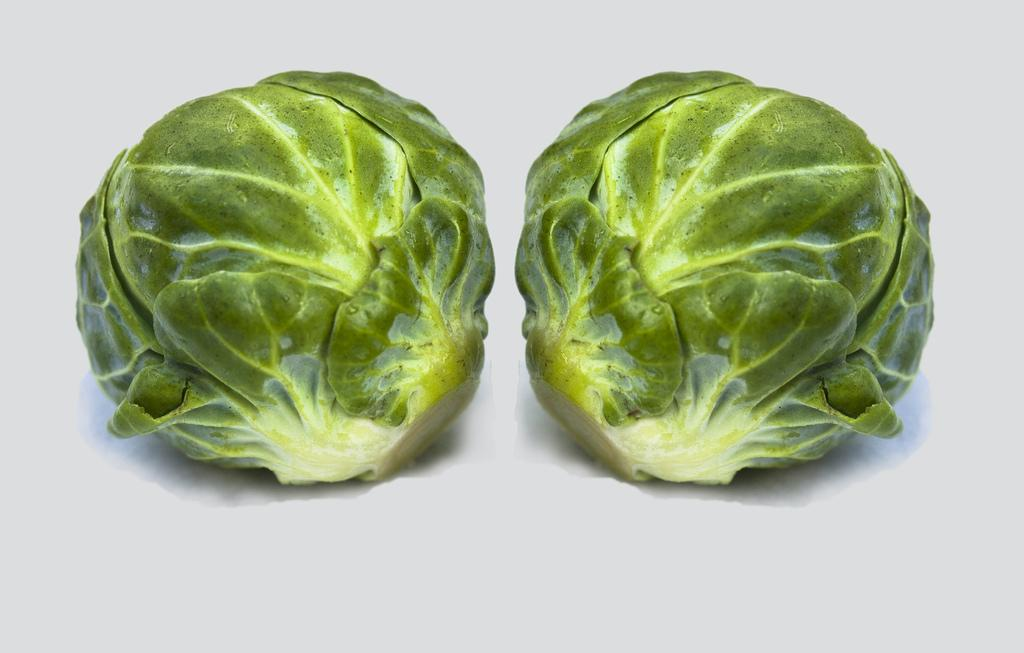What vegetables are present in the image? There are two cabbages in the image. What is the color of the surface on which the cabbages are placed? The cabbages are on a white surface. What type of bead is used to decorate the cabbages in the image? There are no beads present in the image, and the cabbages are not decorated. What financial value do the cabbages have in the image? The image does not provide any information about the financial value of the cabbages. 